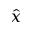<formula> <loc_0><loc_0><loc_500><loc_500>\hat { x }</formula> 